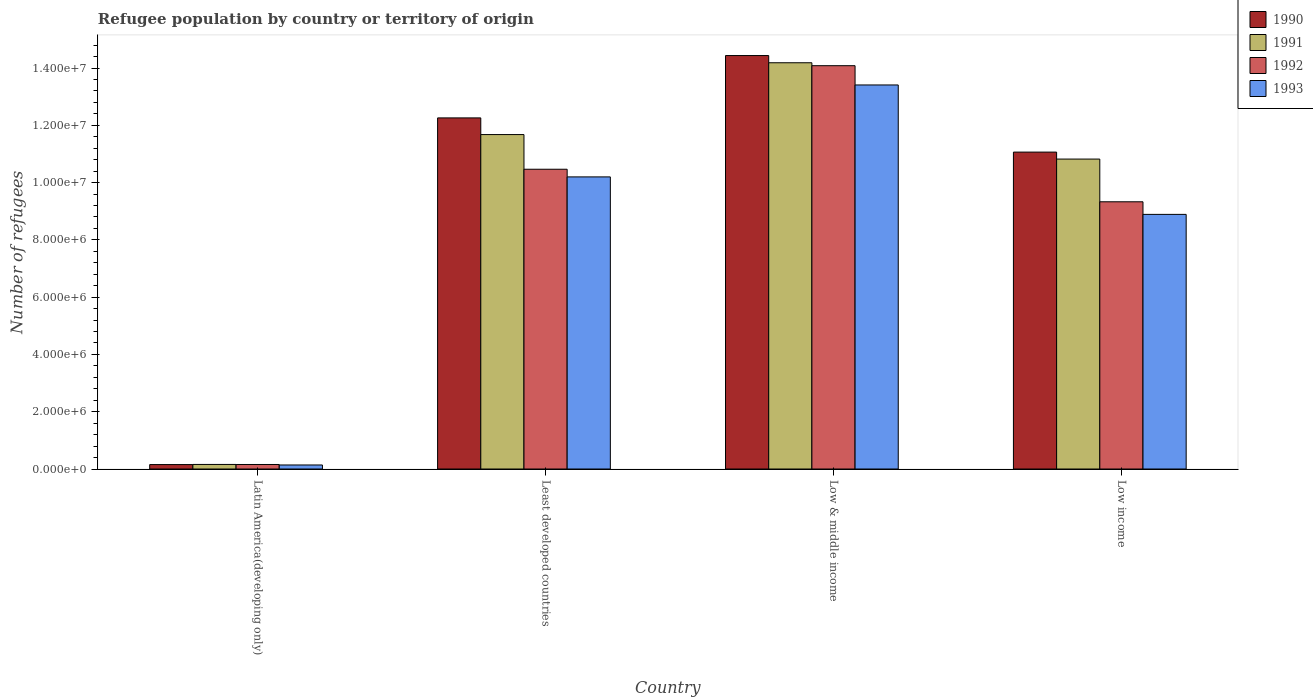How many groups of bars are there?
Give a very brief answer. 4. Are the number of bars on each tick of the X-axis equal?
Provide a succinct answer. Yes. How many bars are there on the 1st tick from the left?
Give a very brief answer. 4. What is the label of the 1st group of bars from the left?
Give a very brief answer. Latin America(developing only). What is the number of refugees in 1991 in Low & middle income?
Make the answer very short. 1.42e+07. Across all countries, what is the maximum number of refugees in 1992?
Ensure brevity in your answer.  1.41e+07. Across all countries, what is the minimum number of refugees in 1992?
Your response must be concise. 1.58e+05. In which country was the number of refugees in 1991 minimum?
Offer a terse response. Latin America(developing only). What is the total number of refugees in 1991 in the graph?
Offer a very short reply. 3.68e+07. What is the difference between the number of refugees in 1991 in Latin America(developing only) and that in Low income?
Provide a succinct answer. -1.07e+07. What is the difference between the number of refugees in 1990 in Least developed countries and the number of refugees in 1992 in Latin America(developing only)?
Your answer should be very brief. 1.21e+07. What is the average number of refugees in 1990 per country?
Give a very brief answer. 9.48e+06. What is the difference between the number of refugees of/in 1992 and number of refugees of/in 1991 in Least developed countries?
Give a very brief answer. -1.21e+06. What is the ratio of the number of refugees in 1991 in Latin America(developing only) to that in Low income?
Make the answer very short. 0.01. What is the difference between the highest and the second highest number of refugees in 1992?
Keep it short and to the point. -3.62e+06. What is the difference between the highest and the lowest number of refugees in 1992?
Ensure brevity in your answer.  1.39e+07. What does the 4th bar from the right in Latin America(developing only) represents?
Provide a short and direct response. 1990. Is it the case that in every country, the sum of the number of refugees in 1993 and number of refugees in 1990 is greater than the number of refugees in 1991?
Make the answer very short. Yes. How many bars are there?
Ensure brevity in your answer.  16. How many countries are there in the graph?
Your answer should be compact. 4. Does the graph contain any zero values?
Your answer should be very brief. No. Where does the legend appear in the graph?
Offer a terse response. Top right. What is the title of the graph?
Provide a short and direct response. Refugee population by country or territory of origin. Does "1963" appear as one of the legend labels in the graph?
Ensure brevity in your answer.  No. What is the label or title of the X-axis?
Your answer should be compact. Country. What is the label or title of the Y-axis?
Keep it short and to the point. Number of refugees. What is the Number of refugees in 1990 in Latin America(developing only)?
Provide a short and direct response. 1.55e+05. What is the Number of refugees in 1991 in Latin America(developing only)?
Provide a short and direct response. 1.60e+05. What is the Number of refugees in 1992 in Latin America(developing only)?
Give a very brief answer. 1.58e+05. What is the Number of refugees in 1993 in Latin America(developing only)?
Give a very brief answer. 1.41e+05. What is the Number of refugees in 1990 in Least developed countries?
Provide a short and direct response. 1.23e+07. What is the Number of refugees of 1991 in Least developed countries?
Offer a very short reply. 1.17e+07. What is the Number of refugees of 1992 in Least developed countries?
Offer a very short reply. 1.05e+07. What is the Number of refugees of 1993 in Least developed countries?
Offer a very short reply. 1.02e+07. What is the Number of refugees in 1990 in Low & middle income?
Ensure brevity in your answer.  1.44e+07. What is the Number of refugees of 1991 in Low & middle income?
Your answer should be compact. 1.42e+07. What is the Number of refugees of 1992 in Low & middle income?
Provide a succinct answer. 1.41e+07. What is the Number of refugees in 1993 in Low & middle income?
Offer a terse response. 1.34e+07. What is the Number of refugees of 1990 in Low income?
Offer a very short reply. 1.11e+07. What is the Number of refugees in 1991 in Low income?
Your answer should be very brief. 1.08e+07. What is the Number of refugees in 1992 in Low income?
Your answer should be very brief. 9.33e+06. What is the Number of refugees in 1993 in Low income?
Keep it short and to the point. 8.89e+06. Across all countries, what is the maximum Number of refugees in 1990?
Offer a very short reply. 1.44e+07. Across all countries, what is the maximum Number of refugees in 1991?
Your answer should be compact. 1.42e+07. Across all countries, what is the maximum Number of refugees of 1992?
Provide a succinct answer. 1.41e+07. Across all countries, what is the maximum Number of refugees of 1993?
Provide a succinct answer. 1.34e+07. Across all countries, what is the minimum Number of refugees of 1990?
Keep it short and to the point. 1.55e+05. Across all countries, what is the minimum Number of refugees of 1991?
Offer a terse response. 1.60e+05. Across all countries, what is the minimum Number of refugees in 1992?
Offer a very short reply. 1.58e+05. Across all countries, what is the minimum Number of refugees of 1993?
Offer a terse response. 1.41e+05. What is the total Number of refugees of 1990 in the graph?
Give a very brief answer. 3.79e+07. What is the total Number of refugees of 1991 in the graph?
Provide a succinct answer. 3.68e+07. What is the total Number of refugees in 1992 in the graph?
Make the answer very short. 3.40e+07. What is the total Number of refugees in 1993 in the graph?
Provide a short and direct response. 3.26e+07. What is the difference between the Number of refugees in 1990 in Latin America(developing only) and that in Least developed countries?
Your answer should be very brief. -1.21e+07. What is the difference between the Number of refugees in 1991 in Latin America(developing only) and that in Least developed countries?
Offer a very short reply. -1.15e+07. What is the difference between the Number of refugees in 1992 in Latin America(developing only) and that in Least developed countries?
Offer a very short reply. -1.03e+07. What is the difference between the Number of refugees in 1993 in Latin America(developing only) and that in Least developed countries?
Keep it short and to the point. -1.01e+07. What is the difference between the Number of refugees of 1990 in Latin America(developing only) and that in Low & middle income?
Offer a terse response. -1.43e+07. What is the difference between the Number of refugees of 1991 in Latin America(developing only) and that in Low & middle income?
Your answer should be very brief. -1.40e+07. What is the difference between the Number of refugees of 1992 in Latin America(developing only) and that in Low & middle income?
Ensure brevity in your answer.  -1.39e+07. What is the difference between the Number of refugees of 1993 in Latin America(developing only) and that in Low & middle income?
Your answer should be compact. -1.33e+07. What is the difference between the Number of refugees in 1990 in Latin America(developing only) and that in Low income?
Make the answer very short. -1.09e+07. What is the difference between the Number of refugees in 1991 in Latin America(developing only) and that in Low income?
Keep it short and to the point. -1.07e+07. What is the difference between the Number of refugees of 1992 in Latin America(developing only) and that in Low income?
Offer a terse response. -9.17e+06. What is the difference between the Number of refugees in 1993 in Latin America(developing only) and that in Low income?
Provide a succinct answer. -8.75e+06. What is the difference between the Number of refugees of 1990 in Least developed countries and that in Low & middle income?
Your answer should be very brief. -2.18e+06. What is the difference between the Number of refugees in 1991 in Least developed countries and that in Low & middle income?
Keep it short and to the point. -2.51e+06. What is the difference between the Number of refugees in 1992 in Least developed countries and that in Low & middle income?
Your answer should be very brief. -3.62e+06. What is the difference between the Number of refugees in 1993 in Least developed countries and that in Low & middle income?
Your answer should be compact. -3.21e+06. What is the difference between the Number of refugees in 1990 in Least developed countries and that in Low income?
Provide a succinct answer. 1.19e+06. What is the difference between the Number of refugees of 1991 in Least developed countries and that in Low income?
Ensure brevity in your answer.  8.55e+05. What is the difference between the Number of refugees of 1992 in Least developed countries and that in Low income?
Offer a very short reply. 1.14e+06. What is the difference between the Number of refugees in 1993 in Least developed countries and that in Low income?
Provide a short and direct response. 1.31e+06. What is the difference between the Number of refugees in 1990 in Low & middle income and that in Low income?
Ensure brevity in your answer.  3.37e+06. What is the difference between the Number of refugees of 1991 in Low & middle income and that in Low income?
Offer a terse response. 3.36e+06. What is the difference between the Number of refugees in 1992 in Low & middle income and that in Low income?
Provide a succinct answer. 4.75e+06. What is the difference between the Number of refugees in 1993 in Low & middle income and that in Low income?
Your response must be concise. 4.52e+06. What is the difference between the Number of refugees of 1990 in Latin America(developing only) and the Number of refugees of 1991 in Least developed countries?
Give a very brief answer. -1.15e+07. What is the difference between the Number of refugees in 1990 in Latin America(developing only) and the Number of refugees in 1992 in Least developed countries?
Ensure brevity in your answer.  -1.03e+07. What is the difference between the Number of refugees of 1990 in Latin America(developing only) and the Number of refugees of 1993 in Least developed countries?
Ensure brevity in your answer.  -1.00e+07. What is the difference between the Number of refugees in 1991 in Latin America(developing only) and the Number of refugees in 1992 in Least developed countries?
Your response must be concise. -1.03e+07. What is the difference between the Number of refugees of 1991 in Latin America(developing only) and the Number of refugees of 1993 in Least developed countries?
Your answer should be very brief. -1.00e+07. What is the difference between the Number of refugees in 1992 in Latin America(developing only) and the Number of refugees in 1993 in Least developed countries?
Your answer should be compact. -1.00e+07. What is the difference between the Number of refugees of 1990 in Latin America(developing only) and the Number of refugees of 1991 in Low & middle income?
Keep it short and to the point. -1.40e+07. What is the difference between the Number of refugees in 1990 in Latin America(developing only) and the Number of refugees in 1992 in Low & middle income?
Offer a terse response. -1.39e+07. What is the difference between the Number of refugees in 1990 in Latin America(developing only) and the Number of refugees in 1993 in Low & middle income?
Offer a very short reply. -1.33e+07. What is the difference between the Number of refugees in 1991 in Latin America(developing only) and the Number of refugees in 1992 in Low & middle income?
Keep it short and to the point. -1.39e+07. What is the difference between the Number of refugees in 1991 in Latin America(developing only) and the Number of refugees in 1993 in Low & middle income?
Offer a terse response. -1.32e+07. What is the difference between the Number of refugees in 1992 in Latin America(developing only) and the Number of refugees in 1993 in Low & middle income?
Your response must be concise. -1.33e+07. What is the difference between the Number of refugees of 1990 in Latin America(developing only) and the Number of refugees of 1991 in Low income?
Keep it short and to the point. -1.07e+07. What is the difference between the Number of refugees in 1990 in Latin America(developing only) and the Number of refugees in 1992 in Low income?
Give a very brief answer. -9.17e+06. What is the difference between the Number of refugees of 1990 in Latin America(developing only) and the Number of refugees of 1993 in Low income?
Give a very brief answer. -8.74e+06. What is the difference between the Number of refugees in 1991 in Latin America(developing only) and the Number of refugees in 1992 in Low income?
Your answer should be very brief. -9.17e+06. What is the difference between the Number of refugees in 1991 in Latin America(developing only) and the Number of refugees in 1993 in Low income?
Your answer should be compact. -8.73e+06. What is the difference between the Number of refugees of 1992 in Latin America(developing only) and the Number of refugees of 1993 in Low income?
Ensure brevity in your answer.  -8.73e+06. What is the difference between the Number of refugees in 1990 in Least developed countries and the Number of refugees in 1991 in Low & middle income?
Make the answer very short. -1.93e+06. What is the difference between the Number of refugees in 1990 in Least developed countries and the Number of refugees in 1992 in Low & middle income?
Make the answer very short. -1.82e+06. What is the difference between the Number of refugees of 1990 in Least developed countries and the Number of refugees of 1993 in Low & middle income?
Make the answer very short. -1.15e+06. What is the difference between the Number of refugees in 1991 in Least developed countries and the Number of refugees in 1992 in Low & middle income?
Your response must be concise. -2.40e+06. What is the difference between the Number of refugees of 1991 in Least developed countries and the Number of refugees of 1993 in Low & middle income?
Your answer should be very brief. -1.73e+06. What is the difference between the Number of refugees in 1992 in Least developed countries and the Number of refugees in 1993 in Low & middle income?
Offer a very short reply. -2.94e+06. What is the difference between the Number of refugees in 1990 in Least developed countries and the Number of refugees in 1991 in Low income?
Provide a succinct answer. 1.44e+06. What is the difference between the Number of refugees in 1990 in Least developed countries and the Number of refugees in 1992 in Low income?
Your response must be concise. 2.93e+06. What is the difference between the Number of refugees in 1990 in Least developed countries and the Number of refugees in 1993 in Low income?
Provide a succinct answer. 3.37e+06. What is the difference between the Number of refugees of 1991 in Least developed countries and the Number of refugees of 1992 in Low income?
Your response must be concise. 2.35e+06. What is the difference between the Number of refugees of 1991 in Least developed countries and the Number of refugees of 1993 in Low income?
Your response must be concise. 2.79e+06. What is the difference between the Number of refugees of 1992 in Least developed countries and the Number of refugees of 1993 in Low income?
Ensure brevity in your answer.  1.58e+06. What is the difference between the Number of refugees in 1990 in Low & middle income and the Number of refugees in 1991 in Low income?
Give a very brief answer. 3.61e+06. What is the difference between the Number of refugees in 1990 in Low & middle income and the Number of refugees in 1992 in Low income?
Provide a succinct answer. 5.11e+06. What is the difference between the Number of refugees in 1990 in Low & middle income and the Number of refugees in 1993 in Low income?
Provide a short and direct response. 5.55e+06. What is the difference between the Number of refugees in 1991 in Low & middle income and the Number of refugees in 1992 in Low income?
Make the answer very short. 4.85e+06. What is the difference between the Number of refugees of 1991 in Low & middle income and the Number of refugees of 1993 in Low income?
Make the answer very short. 5.29e+06. What is the difference between the Number of refugees in 1992 in Low & middle income and the Number of refugees in 1993 in Low income?
Provide a short and direct response. 5.19e+06. What is the average Number of refugees in 1990 per country?
Keep it short and to the point. 9.48e+06. What is the average Number of refugees in 1991 per country?
Your response must be concise. 9.21e+06. What is the average Number of refugees of 1992 per country?
Give a very brief answer. 8.51e+06. What is the average Number of refugees of 1993 per country?
Your answer should be compact. 8.16e+06. What is the difference between the Number of refugees of 1990 and Number of refugees of 1991 in Latin America(developing only)?
Keep it short and to the point. -4784. What is the difference between the Number of refugees of 1990 and Number of refugees of 1992 in Latin America(developing only)?
Ensure brevity in your answer.  -2704. What is the difference between the Number of refugees in 1990 and Number of refugees in 1993 in Latin America(developing only)?
Provide a succinct answer. 1.42e+04. What is the difference between the Number of refugees of 1991 and Number of refugees of 1992 in Latin America(developing only)?
Give a very brief answer. 2080. What is the difference between the Number of refugees of 1991 and Number of refugees of 1993 in Latin America(developing only)?
Your response must be concise. 1.89e+04. What is the difference between the Number of refugees of 1992 and Number of refugees of 1993 in Latin America(developing only)?
Your answer should be very brief. 1.69e+04. What is the difference between the Number of refugees in 1990 and Number of refugees in 1991 in Least developed countries?
Make the answer very short. 5.82e+05. What is the difference between the Number of refugees of 1990 and Number of refugees of 1992 in Least developed countries?
Offer a terse response. 1.79e+06. What is the difference between the Number of refugees of 1990 and Number of refugees of 1993 in Least developed countries?
Ensure brevity in your answer.  2.06e+06. What is the difference between the Number of refugees of 1991 and Number of refugees of 1992 in Least developed countries?
Give a very brief answer. 1.21e+06. What is the difference between the Number of refugees in 1991 and Number of refugees in 1993 in Least developed countries?
Keep it short and to the point. 1.48e+06. What is the difference between the Number of refugees in 1992 and Number of refugees in 1993 in Least developed countries?
Provide a short and direct response. 2.67e+05. What is the difference between the Number of refugees in 1990 and Number of refugees in 1991 in Low & middle income?
Your response must be concise. 2.52e+05. What is the difference between the Number of refugees in 1990 and Number of refugees in 1992 in Low & middle income?
Make the answer very short. 3.54e+05. What is the difference between the Number of refugees in 1990 and Number of refugees in 1993 in Low & middle income?
Your answer should be very brief. 1.03e+06. What is the difference between the Number of refugees in 1991 and Number of refugees in 1992 in Low & middle income?
Your answer should be compact. 1.02e+05. What is the difference between the Number of refugees in 1991 and Number of refugees in 1993 in Low & middle income?
Provide a short and direct response. 7.75e+05. What is the difference between the Number of refugees in 1992 and Number of refugees in 1993 in Low & middle income?
Provide a short and direct response. 6.73e+05. What is the difference between the Number of refugees of 1990 and Number of refugees of 1991 in Low income?
Provide a succinct answer. 2.43e+05. What is the difference between the Number of refugees of 1990 and Number of refugees of 1992 in Low income?
Offer a very short reply. 1.73e+06. What is the difference between the Number of refugees of 1990 and Number of refugees of 1993 in Low income?
Ensure brevity in your answer.  2.17e+06. What is the difference between the Number of refugees in 1991 and Number of refugees in 1992 in Low income?
Your answer should be compact. 1.49e+06. What is the difference between the Number of refugees of 1991 and Number of refugees of 1993 in Low income?
Ensure brevity in your answer.  1.93e+06. What is the difference between the Number of refugees of 1992 and Number of refugees of 1993 in Low income?
Your answer should be compact. 4.40e+05. What is the ratio of the Number of refugees of 1990 in Latin America(developing only) to that in Least developed countries?
Offer a terse response. 0.01. What is the ratio of the Number of refugees in 1991 in Latin America(developing only) to that in Least developed countries?
Provide a short and direct response. 0.01. What is the ratio of the Number of refugees of 1992 in Latin America(developing only) to that in Least developed countries?
Your answer should be very brief. 0.02. What is the ratio of the Number of refugees in 1993 in Latin America(developing only) to that in Least developed countries?
Provide a short and direct response. 0.01. What is the ratio of the Number of refugees of 1990 in Latin America(developing only) to that in Low & middle income?
Make the answer very short. 0.01. What is the ratio of the Number of refugees of 1991 in Latin America(developing only) to that in Low & middle income?
Make the answer very short. 0.01. What is the ratio of the Number of refugees of 1992 in Latin America(developing only) to that in Low & middle income?
Offer a very short reply. 0.01. What is the ratio of the Number of refugees of 1993 in Latin America(developing only) to that in Low & middle income?
Make the answer very short. 0.01. What is the ratio of the Number of refugees of 1990 in Latin America(developing only) to that in Low income?
Keep it short and to the point. 0.01. What is the ratio of the Number of refugees of 1991 in Latin America(developing only) to that in Low income?
Give a very brief answer. 0.01. What is the ratio of the Number of refugees of 1992 in Latin America(developing only) to that in Low income?
Offer a very short reply. 0.02. What is the ratio of the Number of refugees in 1993 in Latin America(developing only) to that in Low income?
Keep it short and to the point. 0.02. What is the ratio of the Number of refugees in 1990 in Least developed countries to that in Low & middle income?
Make the answer very short. 0.85. What is the ratio of the Number of refugees of 1991 in Least developed countries to that in Low & middle income?
Ensure brevity in your answer.  0.82. What is the ratio of the Number of refugees of 1992 in Least developed countries to that in Low & middle income?
Offer a very short reply. 0.74. What is the ratio of the Number of refugees of 1993 in Least developed countries to that in Low & middle income?
Keep it short and to the point. 0.76. What is the ratio of the Number of refugees of 1990 in Least developed countries to that in Low income?
Provide a short and direct response. 1.11. What is the ratio of the Number of refugees of 1991 in Least developed countries to that in Low income?
Offer a very short reply. 1.08. What is the ratio of the Number of refugees in 1992 in Least developed countries to that in Low income?
Provide a succinct answer. 1.12. What is the ratio of the Number of refugees in 1993 in Least developed countries to that in Low income?
Give a very brief answer. 1.15. What is the ratio of the Number of refugees in 1990 in Low & middle income to that in Low income?
Provide a succinct answer. 1.3. What is the ratio of the Number of refugees of 1991 in Low & middle income to that in Low income?
Make the answer very short. 1.31. What is the ratio of the Number of refugees of 1992 in Low & middle income to that in Low income?
Ensure brevity in your answer.  1.51. What is the ratio of the Number of refugees of 1993 in Low & middle income to that in Low income?
Your answer should be very brief. 1.51. What is the difference between the highest and the second highest Number of refugees in 1990?
Provide a succinct answer. 2.18e+06. What is the difference between the highest and the second highest Number of refugees in 1991?
Provide a short and direct response. 2.51e+06. What is the difference between the highest and the second highest Number of refugees of 1992?
Give a very brief answer. 3.62e+06. What is the difference between the highest and the second highest Number of refugees in 1993?
Give a very brief answer. 3.21e+06. What is the difference between the highest and the lowest Number of refugees of 1990?
Offer a very short reply. 1.43e+07. What is the difference between the highest and the lowest Number of refugees of 1991?
Offer a terse response. 1.40e+07. What is the difference between the highest and the lowest Number of refugees in 1992?
Keep it short and to the point. 1.39e+07. What is the difference between the highest and the lowest Number of refugees in 1993?
Provide a succinct answer. 1.33e+07. 